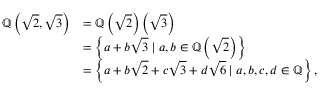<formula> <loc_0><loc_0><loc_500><loc_500>{ \begin{array} { r l } { \mathbb { Q } \left ( { \sqrt { 2 } } , { \sqrt { 3 } } \right ) } & { = \mathbb { Q } \left ( { \sqrt { 2 } } \right ) \left ( { \sqrt { 3 } } \right ) } \\ & { = \left \{ a + b { \sqrt { 3 } } | a , b \in \mathbb { Q } \left ( { \sqrt { 2 } } \right ) \right \} } \\ & { = \left \{ a + b { \sqrt { 2 } } + c { \sqrt { 3 } } + d { \sqrt { 6 } } | a , b , c , d \in \mathbb { Q } \right \} , } \end{array} }</formula> 